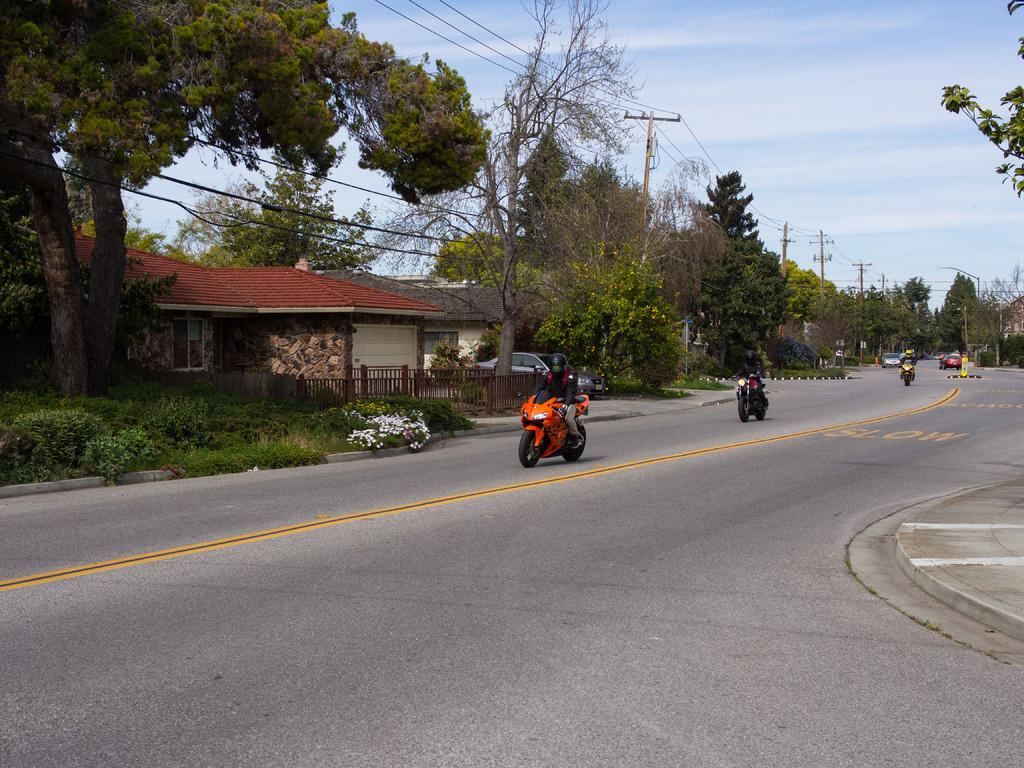What type of vehicles can be seen on the road in the image? There are motor vehicles on the road in the image. What structures are visible in the image? There are buildings in the image. What type of cooking equipment is present? Wooden grills are present in the image. What type of infrastructure is visible in the image? Electric poles and electric cables are present in the image. What type of vegetation can be seen in the image? Trees, shrubs, and grass are visible in the image. What is visible in the background of the image? The sky is visible in the background of the image. What type of pie is being served at the picnic in the image? There is no picnic or pie present in the image. What season is depicted in the image? The image does not depict a specific season; it only shows the presence of trees, shrubs, grass, and clouds in the sky. 